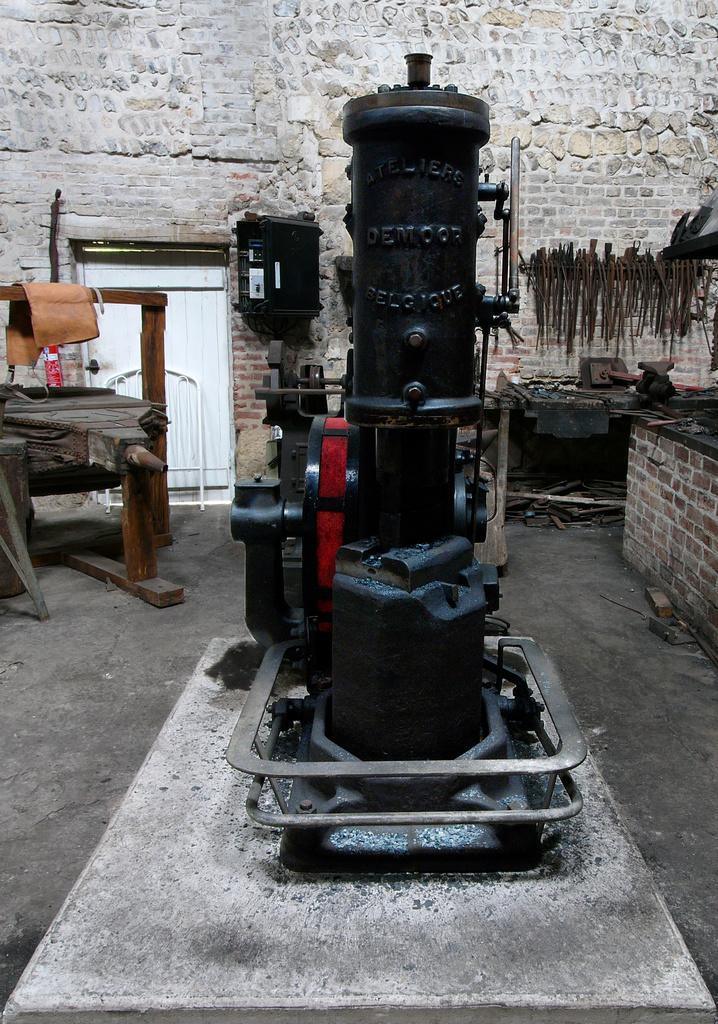Can you describe this image briefly? Here in this picture we can see a machine present on the ground over there and we can also see other machines present and tables present over there and on the wall we can see some equipments present and on the left side we can see a door present over there. 